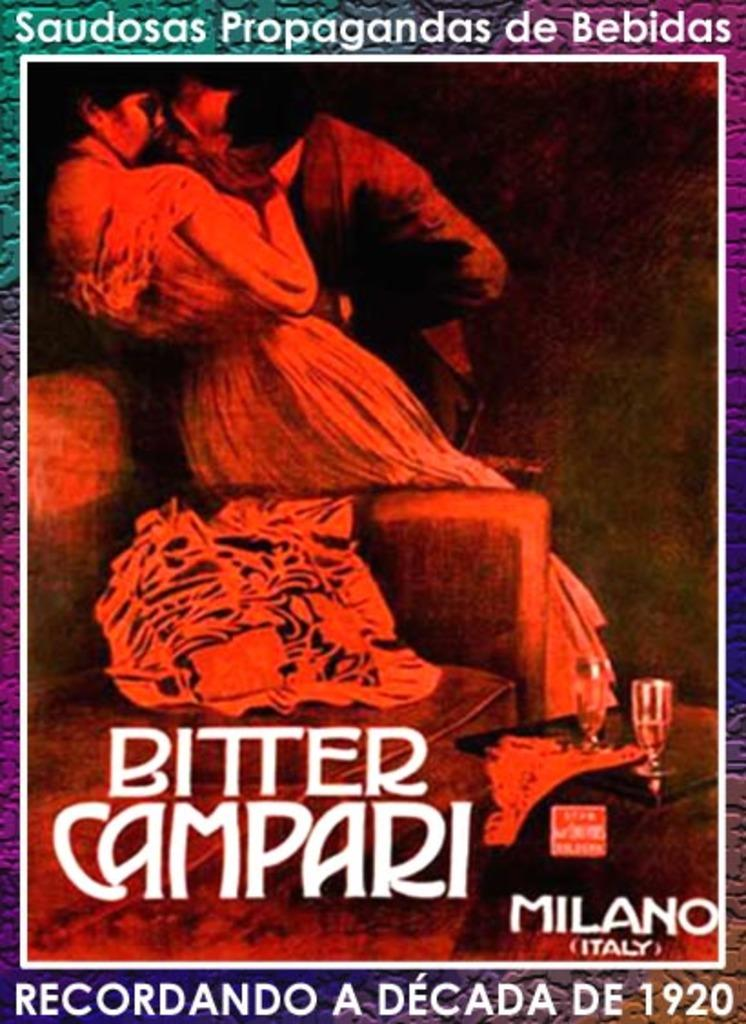<image>
Write a terse but informative summary of the picture. A flyer for the Bitter Campari taking place in Milan Italy. 